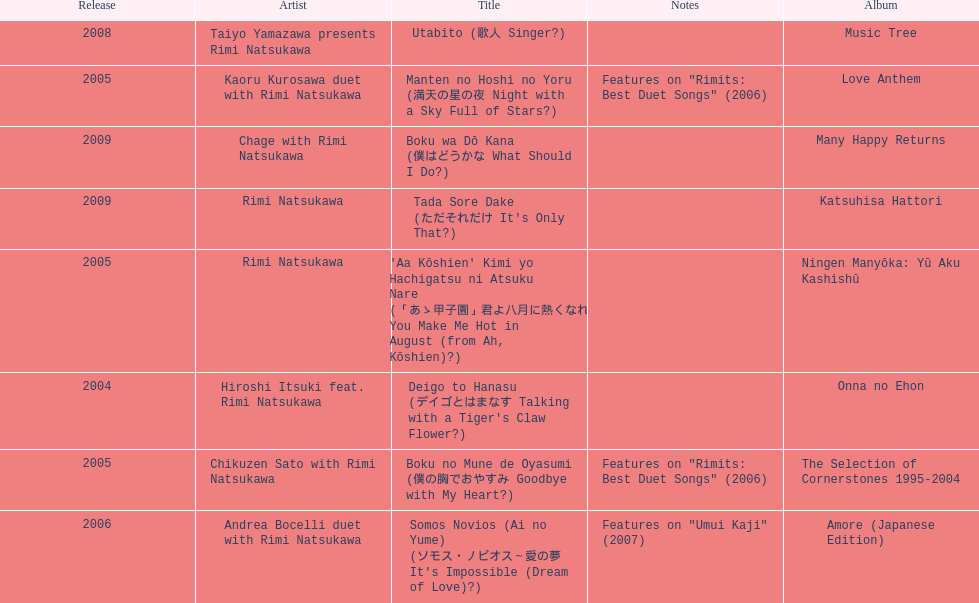Which was not released in 2004, onna no ehon or music tree? Music Tree. 